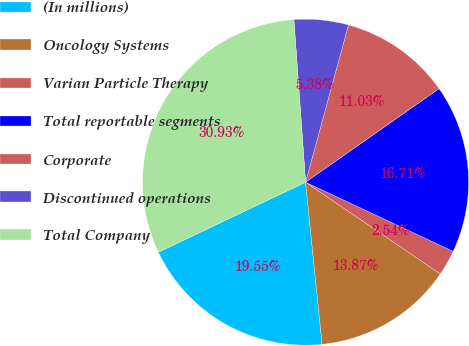Convert chart to OTSL. <chart><loc_0><loc_0><loc_500><loc_500><pie_chart><fcel>(In millions)<fcel>Oncology Systems<fcel>Varian Particle Therapy<fcel>Total reportable segments<fcel>Corporate<fcel>Discontinued operations<fcel>Total Company<nl><fcel>19.55%<fcel>13.87%<fcel>2.54%<fcel>16.71%<fcel>11.03%<fcel>5.38%<fcel>30.93%<nl></chart> 